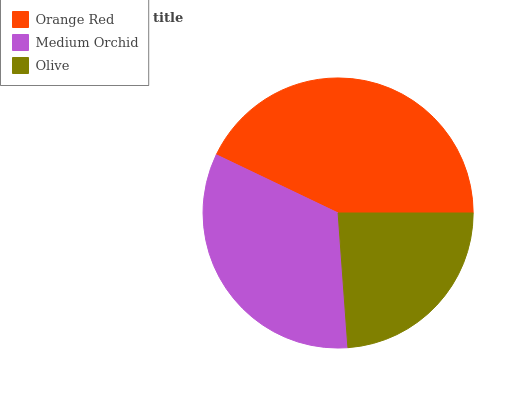Is Olive the minimum?
Answer yes or no. Yes. Is Orange Red the maximum?
Answer yes or no. Yes. Is Medium Orchid the minimum?
Answer yes or no. No. Is Medium Orchid the maximum?
Answer yes or no. No. Is Orange Red greater than Medium Orchid?
Answer yes or no. Yes. Is Medium Orchid less than Orange Red?
Answer yes or no. Yes. Is Medium Orchid greater than Orange Red?
Answer yes or no. No. Is Orange Red less than Medium Orchid?
Answer yes or no. No. Is Medium Orchid the high median?
Answer yes or no. Yes. Is Medium Orchid the low median?
Answer yes or no. Yes. Is Olive the high median?
Answer yes or no. No. Is Orange Red the low median?
Answer yes or no. No. 